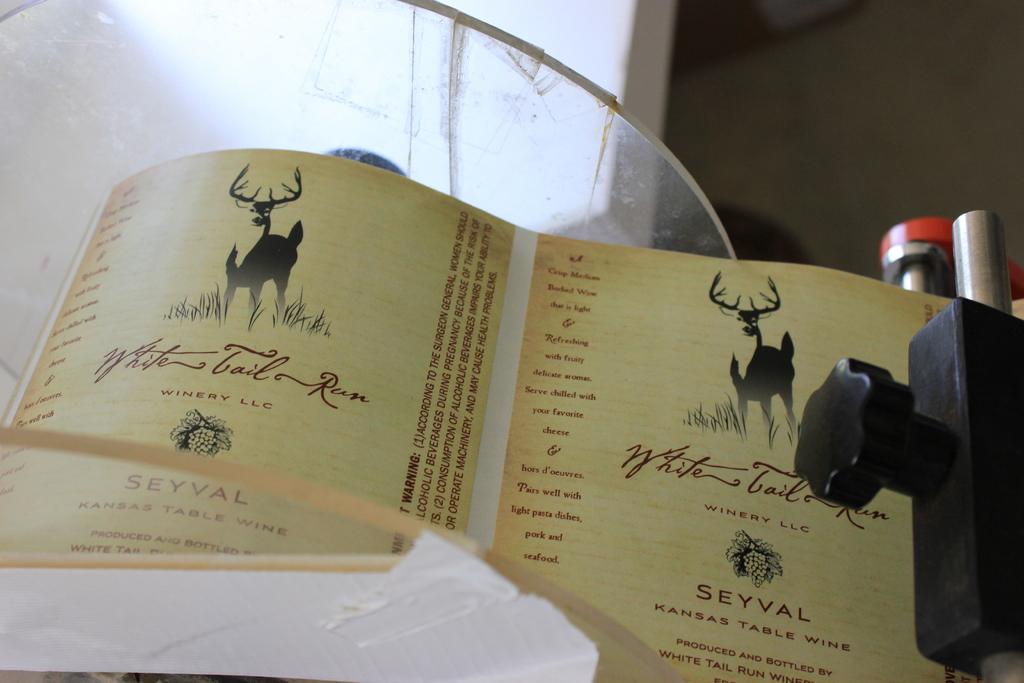What state is this table wine from?
Make the answer very short. Kansas. What beverage is listed on this label?
Give a very brief answer. Kansas table wine. 